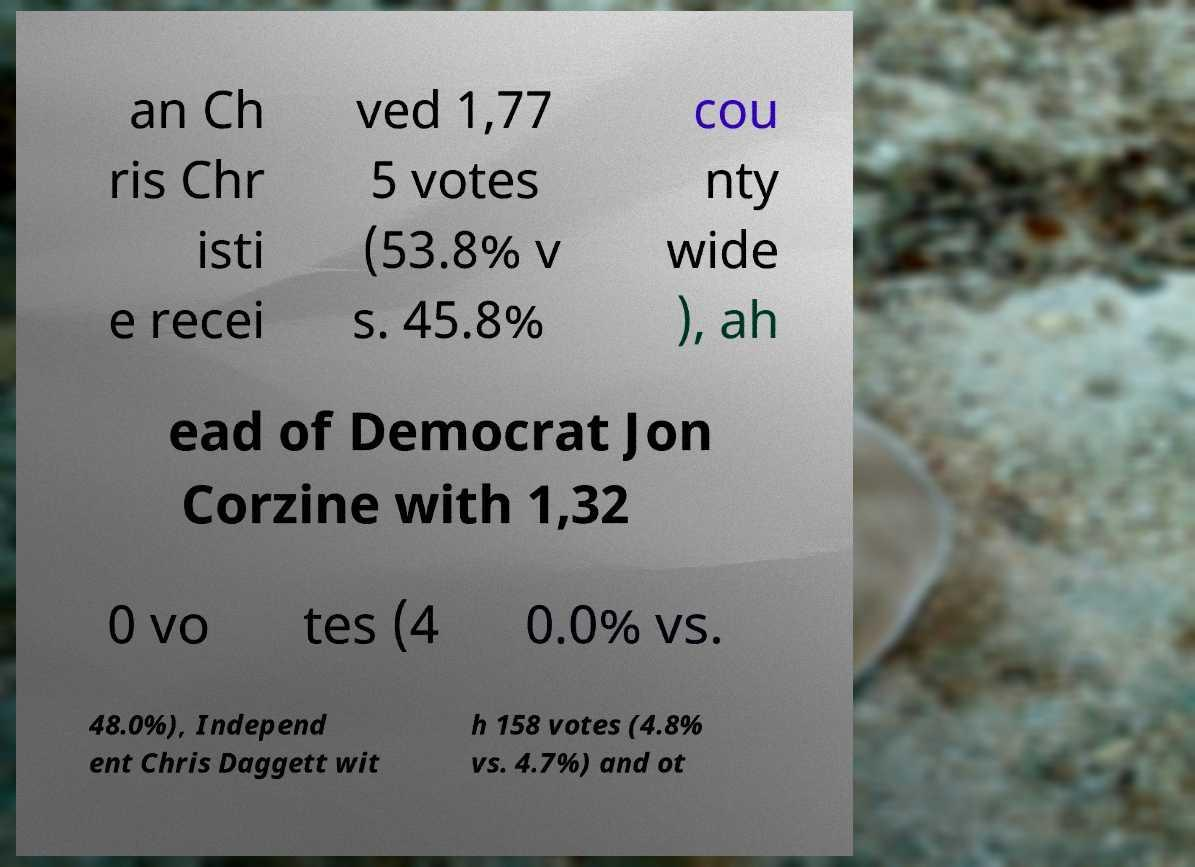Can you read and provide the text displayed in the image?This photo seems to have some interesting text. Can you extract and type it out for me? an Ch ris Chr isti e recei ved 1,77 5 votes (53.8% v s. 45.8% cou nty wide ), ah ead of Democrat Jon Corzine with 1,32 0 vo tes (4 0.0% vs. 48.0%), Independ ent Chris Daggett wit h 158 votes (4.8% vs. 4.7%) and ot 